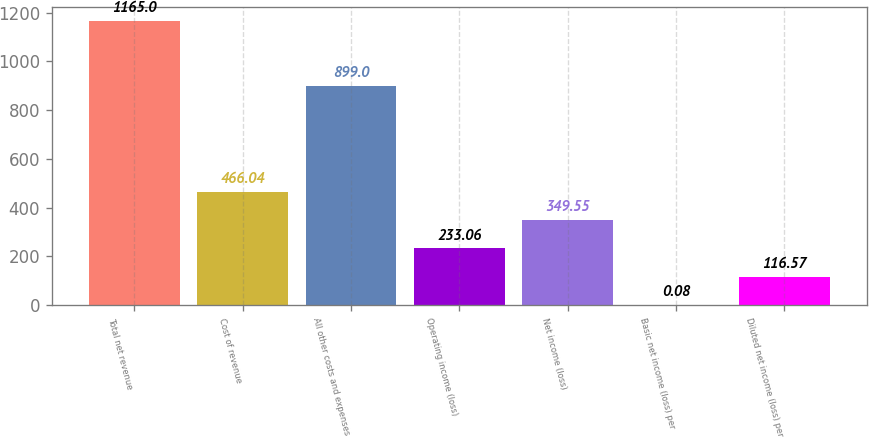<chart> <loc_0><loc_0><loc_500><loc_500><bar_chart><fcel>Total net revenue<fcel>Cost of revenue<fcel>All other costs and expenses<fcel>Operating income (loss)<fcel>Net income (loss)<fcel>Basic net income (loss) per<fcel>Diluted net income (loss) per<nl><fcel>1165<fcel>466.04<fcel>899<fcel>233.06<fcel>349.55<fcel>0.08<fcel>116.57<nl></chart> 